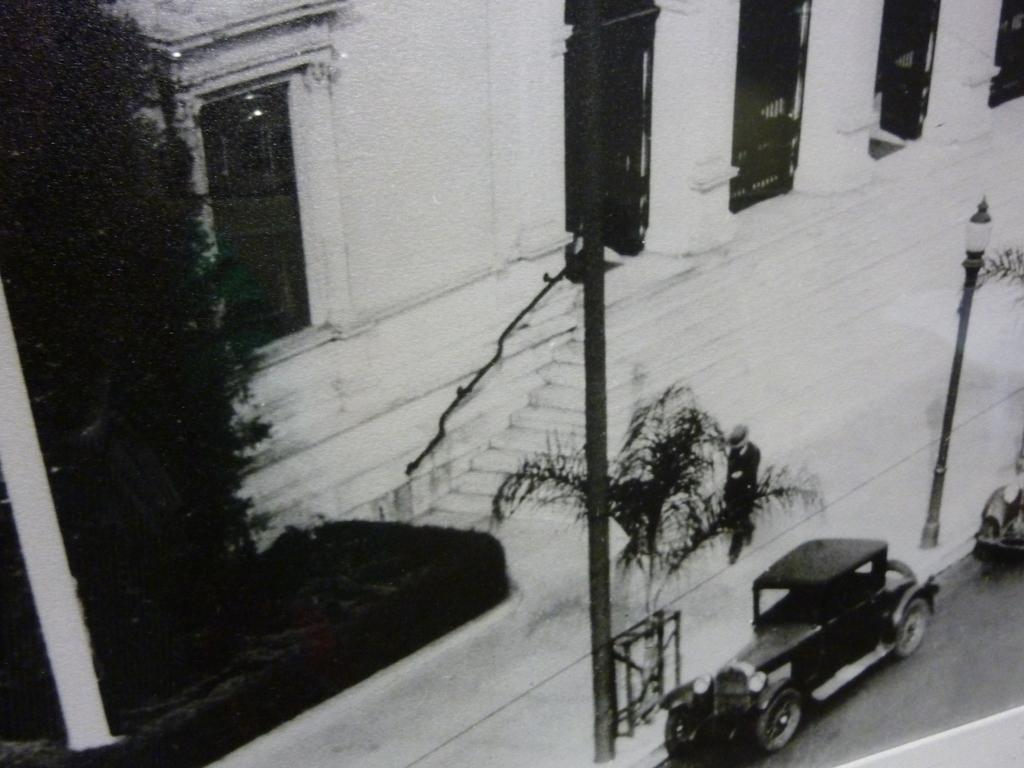What is happening on the road in the image? There are vehicles on the road in the image. What objects can be seen besides the vehicles? There are poles and plants visible in the image. What can be seen in the background of the image? There is a building with a window and steps in the background of the image. How many rings are visible on the fingers of the people in the image? There are no people visible in the image, so it is impossible to determine if there are any rings present. 